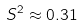Convert formula to latex. <formula><loc_0><loc_0><loc_500><loc_500>S ^ { 2 } \approx 0 . 3 1</formula> 